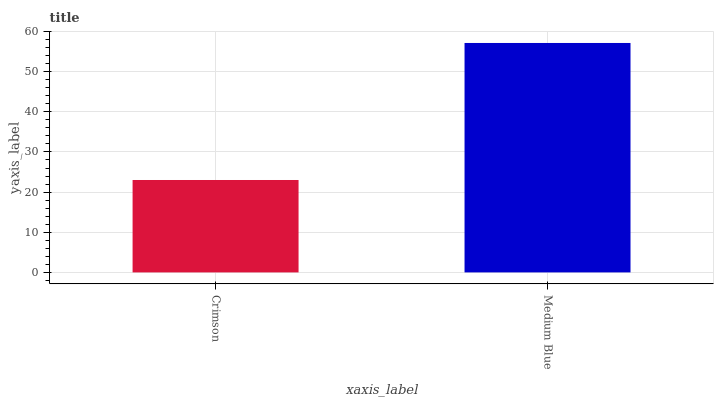Is Medium Blue the minimum?
Answer yes or no. No. Is Medium Blue greater than Crimson?
Answer yes or no. Yes. Is Crimson less than Medium Blue?
Answer yes or no. Yes. Is Crimson greater than Medium Blue?
Answer yes or no. No. Is Medium Blue less than Crimson?
Answer yes or no. No. Is Medium Blue the high median?
Answer yes or no. Yes. Is Crimson the low median?
Answer yes or no. Yes. Is Crimson the high median?
Answer yes or no. No. Is Medium Blue the low median?
Answer yes or no. No. 